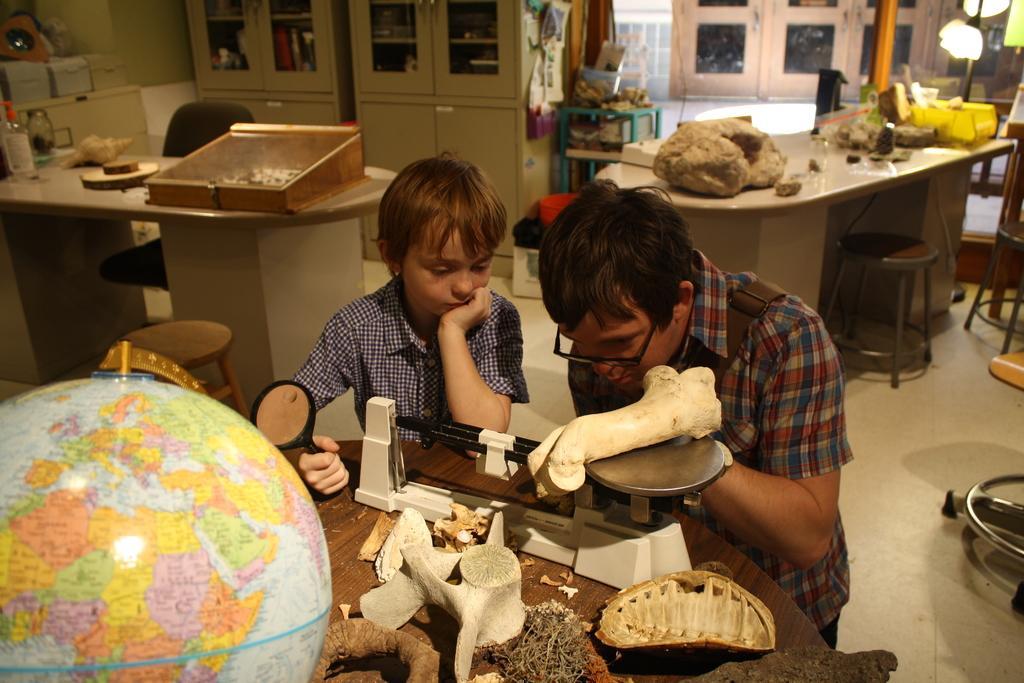Could you give a brief overview of what you see in this image? In this there are two boys. Boy at the right side of image is wearing spectacles standing before a table having bones on it. Boy at the right side is holding a magnifying glass. Left side there is a globe. Left side there is a table having a bottle on it, before there is a stool, behind of it there is a chair. At the top of the image there are two wardrobes. At the right side there is a table, stool and chair. At the right top corner there is a lamp. 